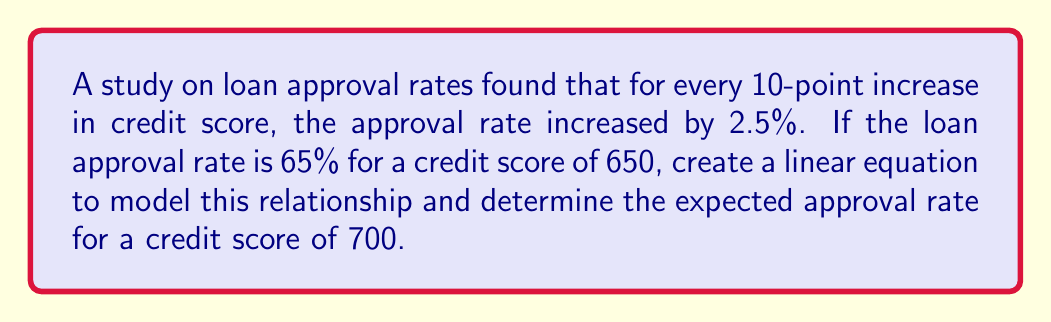Can you answer this question? Let's approach this step-by-step:

1) First, we need to define our variables:
   Let $x$ be the credit score
   Let $y$ be the loan approval rate (in percentage)

2) We're given two points:
   When $x = 650$, $y = 65\%$
   For every 10-point increase in $x$, $y$ increases by 2.5%

3) We can use the point-slope form of a linear equation:
   $y - y_1 = m(x - x_1)$
   Where $m$ is the slope and $(x_1, y_1)$ is a known point

4) Calculate the slope:
   $m = \frac{\text{change in } y}{\text{change in } x} = \frac{2.5\%}{10} = 0.25\%$ per point

5) Now we can form our equation:
   $y - 65 = 0.25(x - 650)$

6) Simplify:
   $y = 0.25x - 162.5 + 65$
   $y = 0.25x - 97.5$

7) To find the approval rate for a credit score of 700:
   $y = 0.25(700) - 97.5$
   $y = 175 - 97.5 = 77.5\%$
Answer: The linear equation is $y = 0.25x - 97.5$, where $x$ is the credit score and $y$ is the approval rate in percentage. The expected approval rate for a credit score of 700 is 77.5%. 